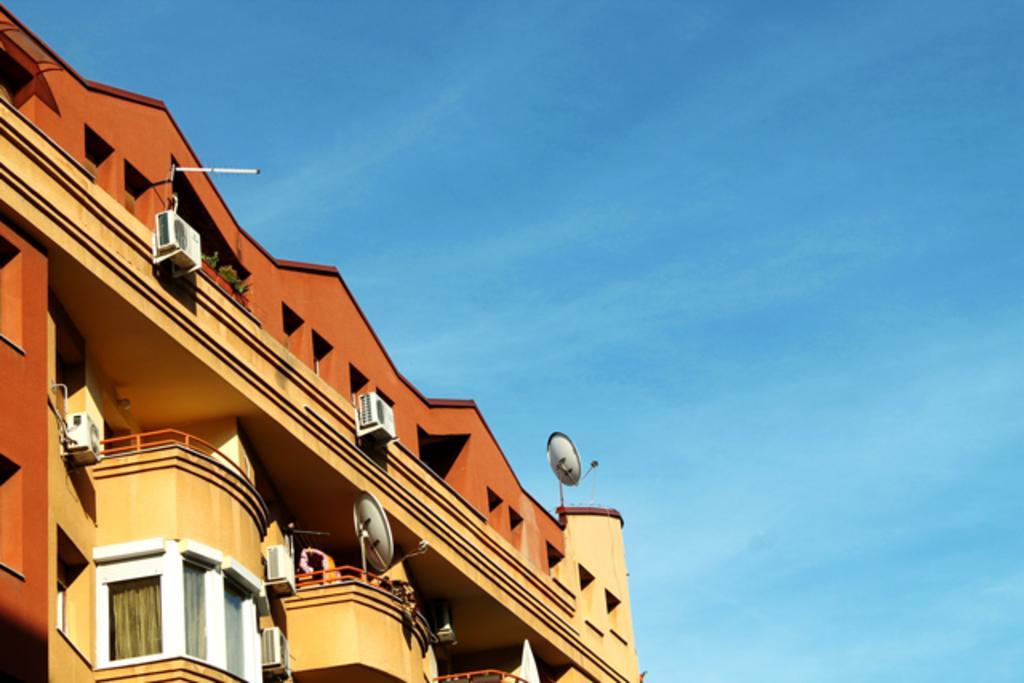Could you give a brief overview of what you see in this image? In this picture I can see a building in front and in the background I see the blue sky. 